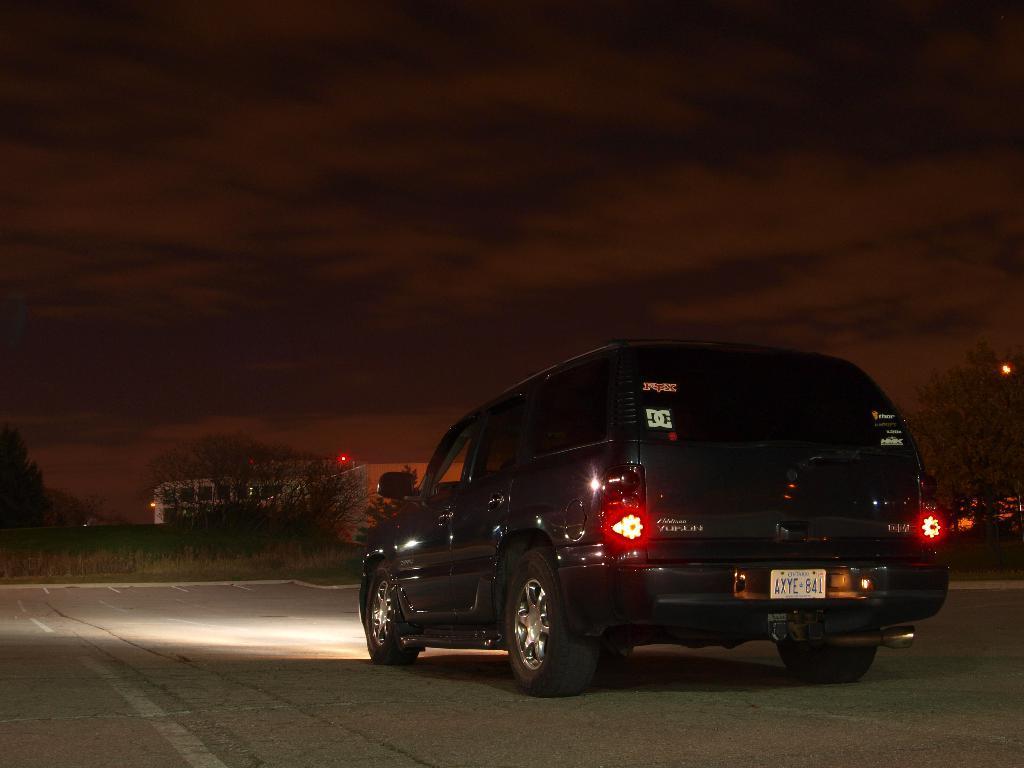In one or two sentences, can you explain what this image depicts? In this picture there is a vehicle on the road and there is a greenery ground in front of it and there is a tree in the right corner and there are few trees and a building in the background. 